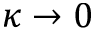<formula> <loc_0><loc_0><loc_500><loc_500>\kappa \rightarrow 0</formula> 